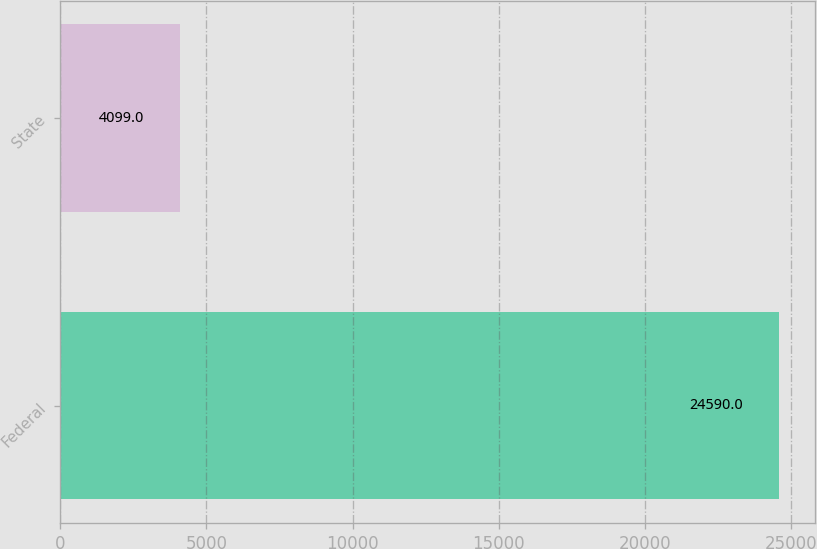<chart> <loc_0><loc_0><loc_500><loc_500><bar_chart><fcel>Federal<fcel>State<nl><fcel>24590<fcel>4099<nl></chart> 